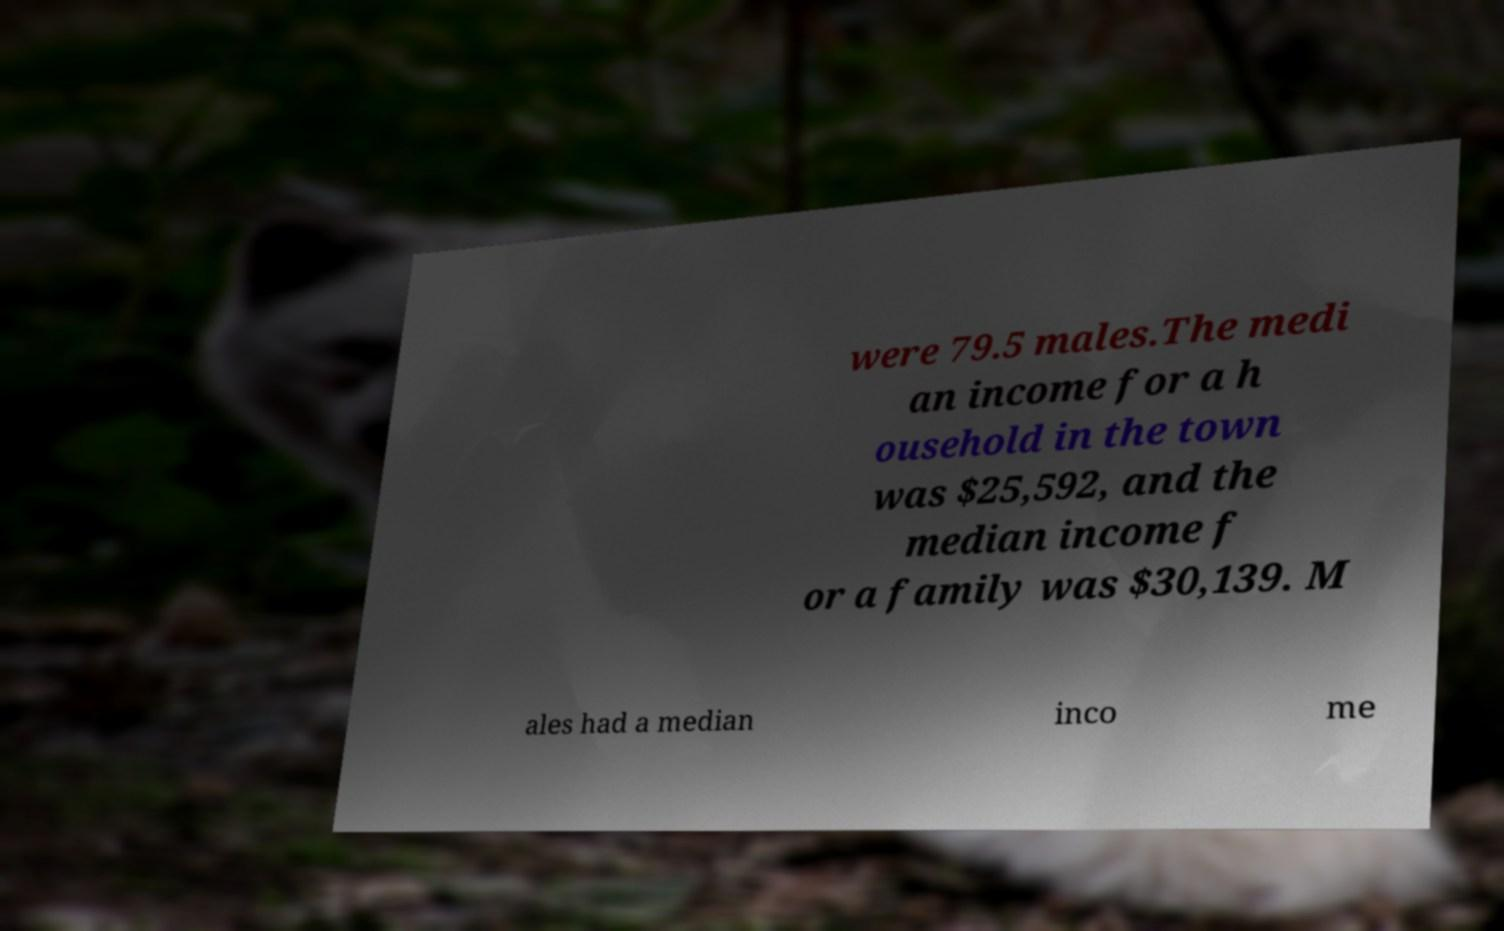Can you read and provide the text displayed in the image?This photo seems to have some interesting text. Can you extract and type it out for me? were 79.5 males.The medi an income for a h ousehold in the town was $25,592, and the median income f or a family was $30,139. M ales had a median inco me 